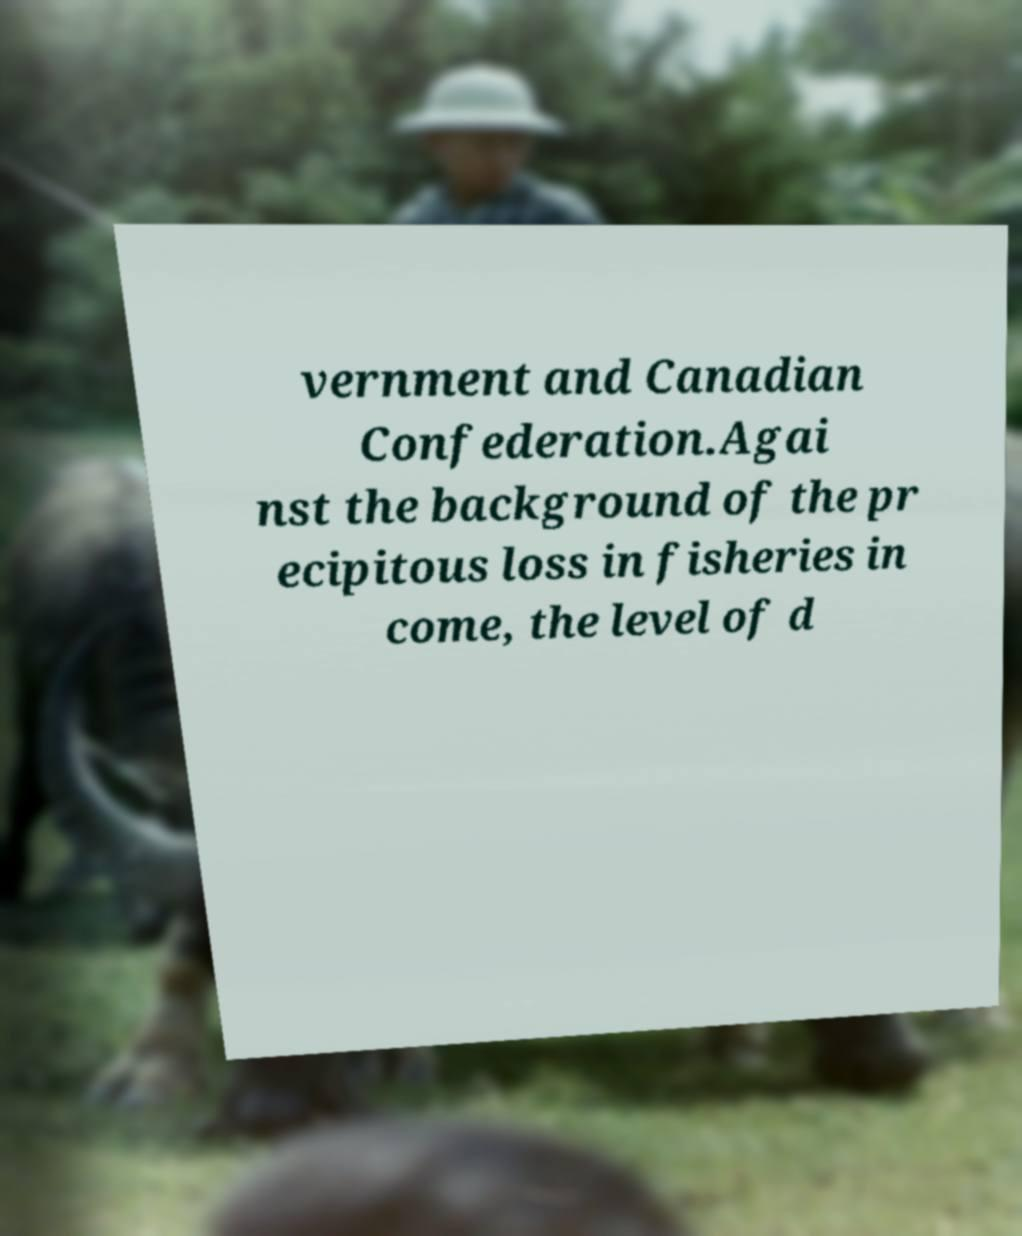Can you accurately transcribe the text from the provided image for me? vernment and Canadian Confederation.Agai nst the background of the pr ecipitous loss in fisheries in come, the level of d 